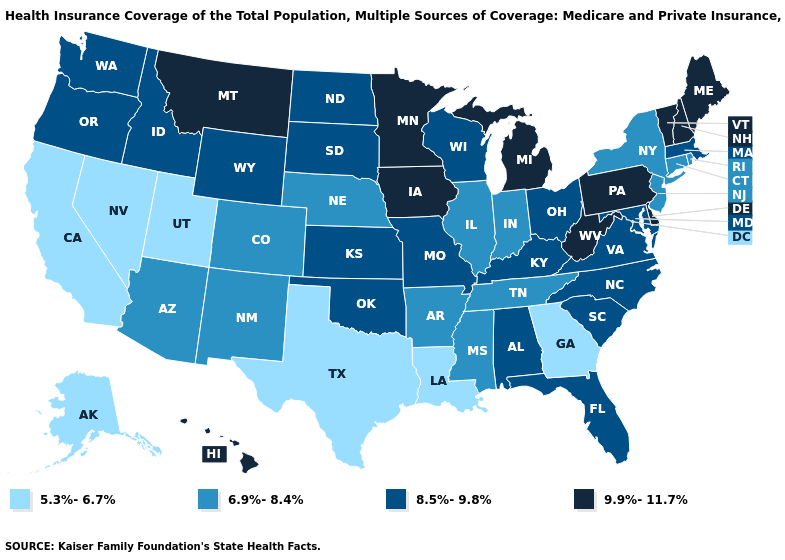Does Minnesota have the same value as New Hampshire?
Answer briefly. Yes. Does Missouri have the highest value in the USA?
Keep it brief. No. Does the first symbol in the legend represent the smallest category?
Give a very brief answer. Yes. What is the highest value in the MidWest ?
Keep it brief. 9.9%-11.7%. Does Georgia have the lowest value in the South?
Write a very short answer. Yes. What is the value of Colorado?
Concise answer only. 6.9%-8.4%. What is the lowest value in the USA?
Be succinct. 5.3%-6.7%. What is the value of Tennessee?
Answer briefly. 6.9%-8.4%. What is the value of Wyoming?
Short answer required. 8.5%-9.8%. Does Indiana have the lowest value in the MidWest?
Be succinct. Yes. What is the value of Iowa?
Answer briefly. 9.9%-11.7%. Does Alabama have a higher value than California?
Keep it brief. Yes. Does Pennsylvania have the lowest value in the USA?
Give a very brief answer. No. What is the value of Montana?
Write a very short answer. 9.9%-11.7%. Does the first symbol in the legend represent the smallest category?
Keep it brief. Yes. 